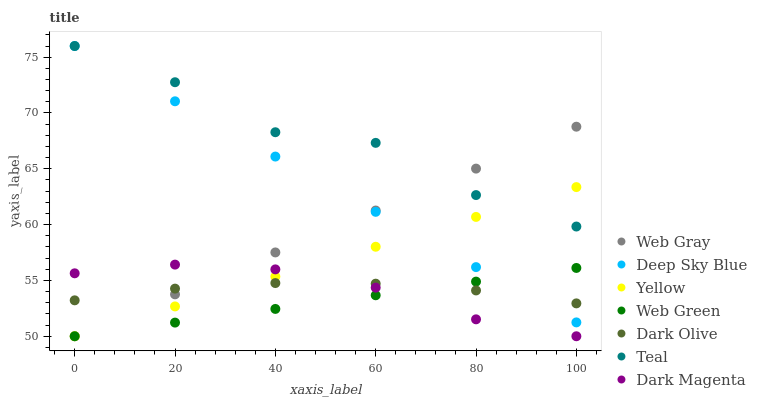Does Web Green have the minimum area under the curve?
Answer yes or no. Yes. Does Teal have the maximum area under the curve?
Answer yes or no. Yes. Does Deep Sky Blue have the minimum area under the curve?
Answer yes or no. No. Does Deep Sky Blue have the maximum area under the curve?
Answer yes or no. No. Is Web Gray the smoothest?
Answer yes or no. Yes. Is Teal the roughest?
Answer yes or no. Yes. Is Deep Sky Blue the smoothest?
Answer yes or no. No. Is Deep Sky Blue the roughest?
Answer yes or no. No. Does Web Gray have the lowest value?
Answer yes or no. Yes. Does Deep Sky Blue have the lowest value?
Answer yes or no. No. Does Teal have the highest value?
Answer yes or no. Yes. Does Dark Olive have the highest value?
Answer yes or no. No. Is Dark Olive less than Teal?
Answer yes or no. Yes. Is Teal greater than Dark Magenta?
Answer yes or no. Yes. Does Web Gray intersect Web Green?
Answer yes or no. Yes. Is Web Gray less than Web Green?
Answer yes or no. No. Is Web Gray greater than Web Green?
Answer yes or no. No. Does Dark Olive intersect Teal?
Answer yes or no. No. 